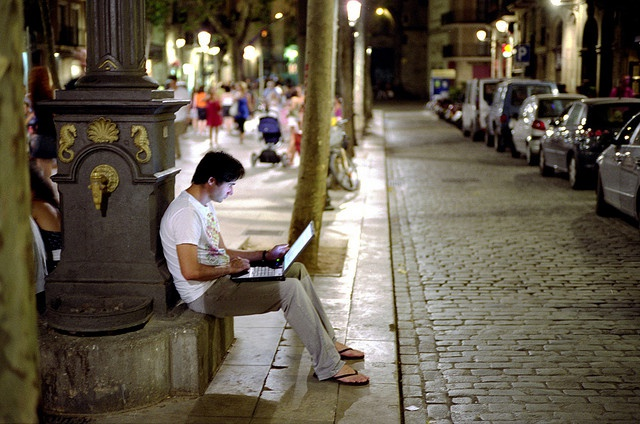Describe the objects in this image and their specific colors. I can see people in black, gray, darkgray, and lavender tones, car in black, gray, darkgreen, and maroon tones, people in black, maroon, and gray tones, car in black and gray tones, and car in black, gray, and darkgray tones in this image. 